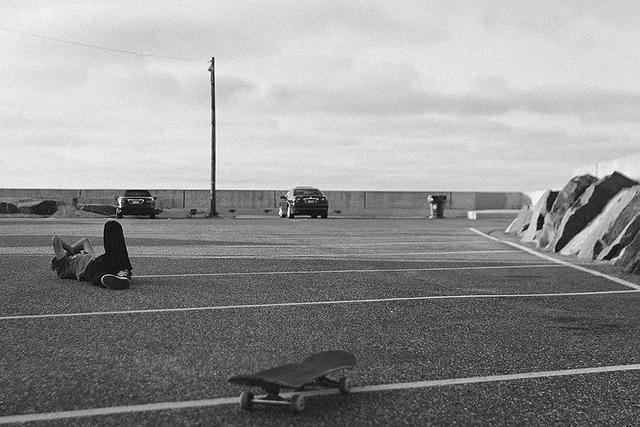Did this man fall off of the skateboard?
Answer briefly. Yes. Is the parking lot full?
Give a very brief answer. No. Is this a skate park?
Keep it brief. No. 